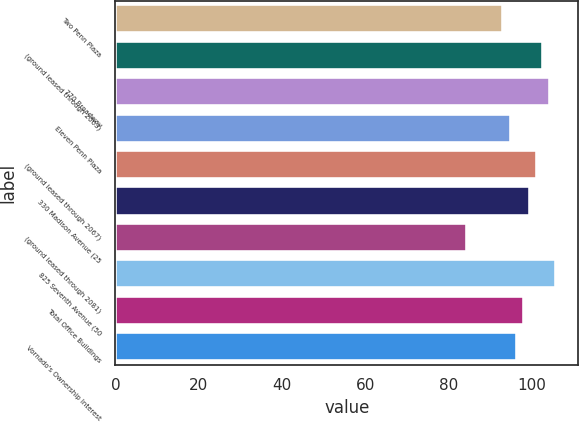<chart> <loc_0><loc_0><loc_500><loc_500><bar_chart><fcel>Two Penn Plaza<fcel>(ground leased through 2063)<fcel>770 Broadway<fcel>Eleven Penn Plaza<fcel>(ground leased through 2067)<fcel>330 Madison Avenue (25<fcel>(ground leased through 2081)<fcel>825 Seventh Avenue (50<fcel>Total Office Buildings<fcel>Vornado's Ownership Interest<nl><fcel>93.2<fcel>102.7<fcel>104.26<fcel>94.9<fcel>101.14<fcel>99.58<fcel>84.4<fcel>105.82<fcel>98.02<fcel>96.46<nl></chart> 